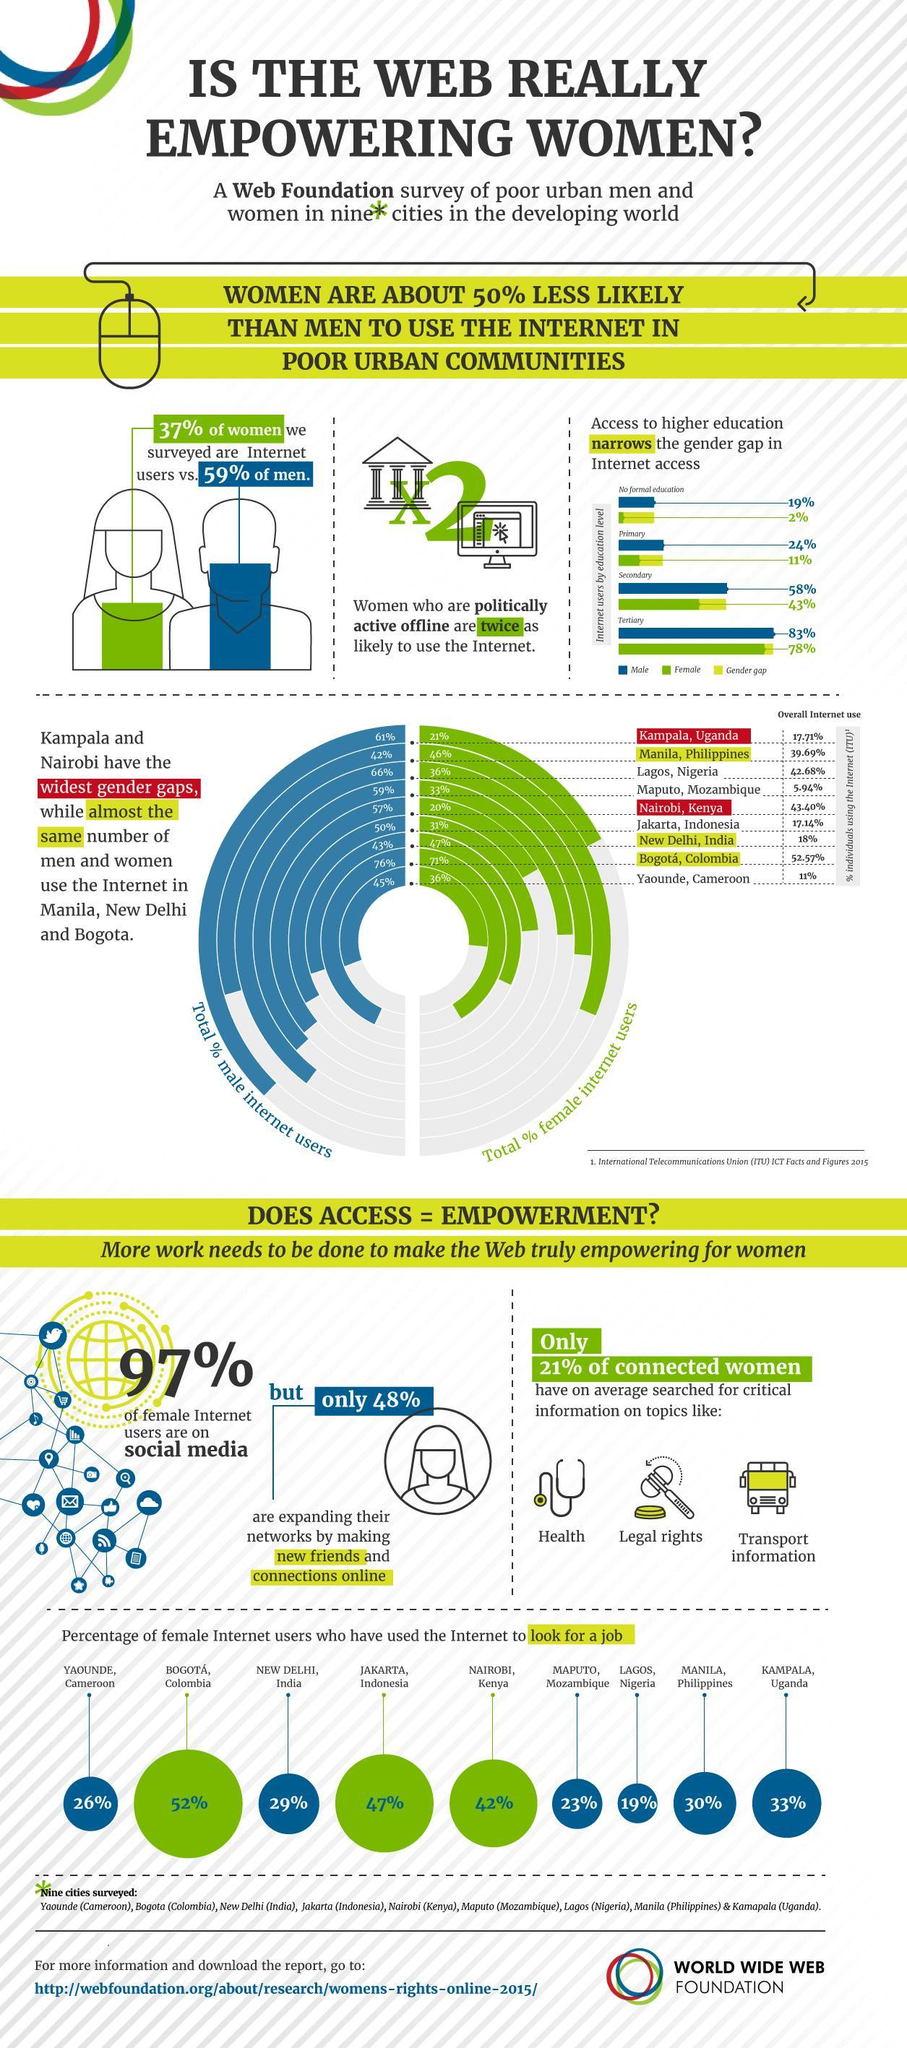People with what education has the highest gender gap in internet access?
Answer the question with a short phrase. No formal education In which city is female internet users looking for a job the least? LAGOS Which cities have percentage of female internet users looking for a job between 20 and 30 %? MAPUTO, YAOUNDE, NEW DELHI Which gender is 11% who has primary education and internet access? Female What percent of men having tertiary education has internet access? 83% Which are the topics that connected women have looked for? Health, Legal rights, Transport information Which gender uses internet more? men Internet users of which education level has a gender gap of 15% in internet access? Secondary In the bar graph which gender is represented by blue colour? Male What is the gender gap in internet access in those with primary education? 13% 